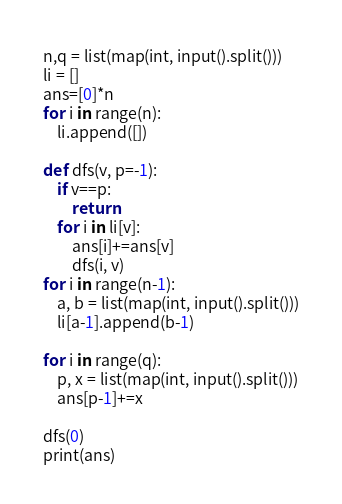<code> <loc_0><loc_0><loc_500><loc_500><_Python_>n,q = list(map(int, input().split()))
li = []
ans=[0]*n
for i in range(n):
    li.append([])

def dfs(v, p=-1):
    if v==p:
        return
    for i in li[v]:
        ans[i]+=ans[v]
        dfs(i, v)
for i in range(n-1):
    a, b = list(map(int, input().split()))
    li[a-1].append(b-1)

for i in range(q):
    p, x = list(map(int, input().split()))
    ans[p-1]+=x

dfs(0)
print(ans)</code> 